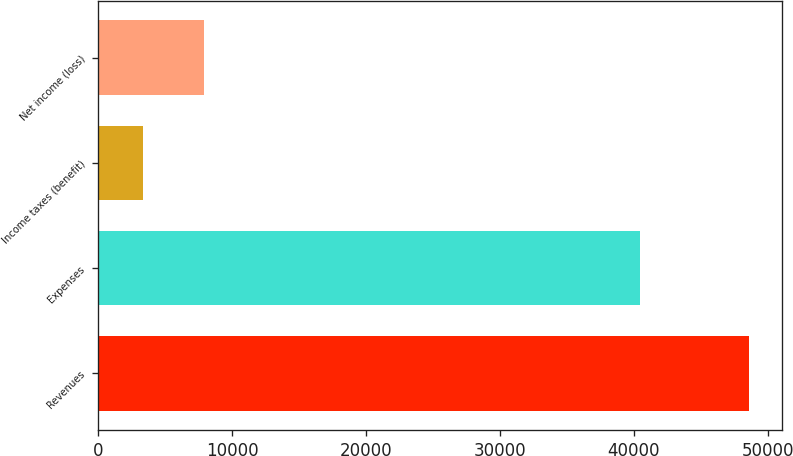Convert chart. <chart><loc_0><loc_0><loc_500><loc_500><bar_chart><fcel>Revenues<fcel>Expenses<fcel>Income taxes (benefit)<fcel>Net income (loss)<nl><fcel>48625<fcel>40422<fcel>3338<fcel>7866.7<nl></chart> 